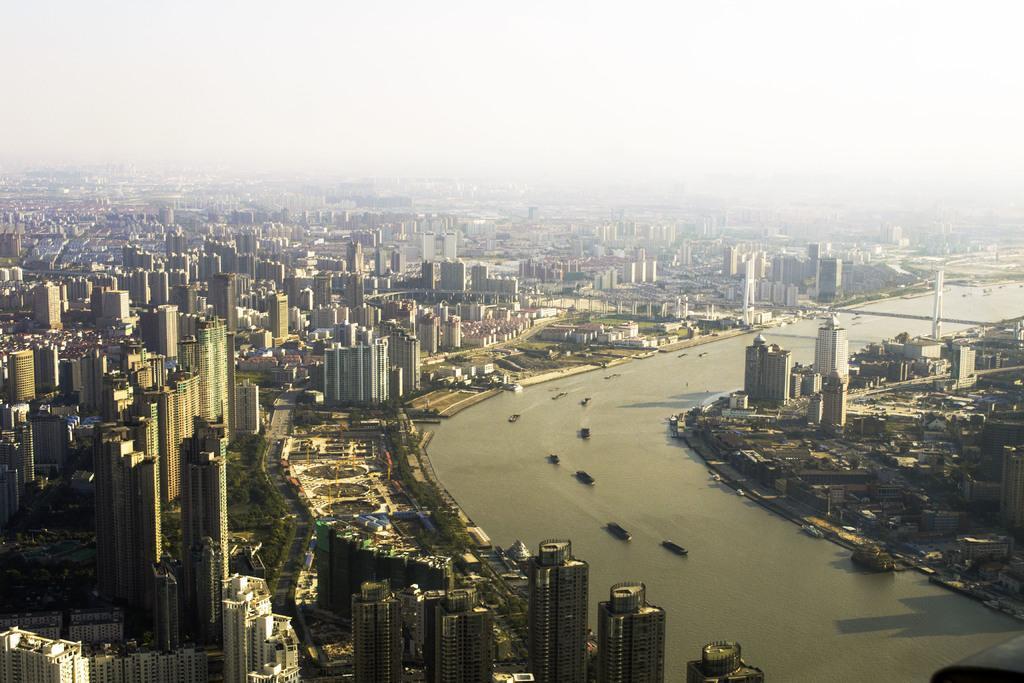Can you describe this image briefly? In this image there are boats in the water. There are buildings. At the top of the image there is sky. 